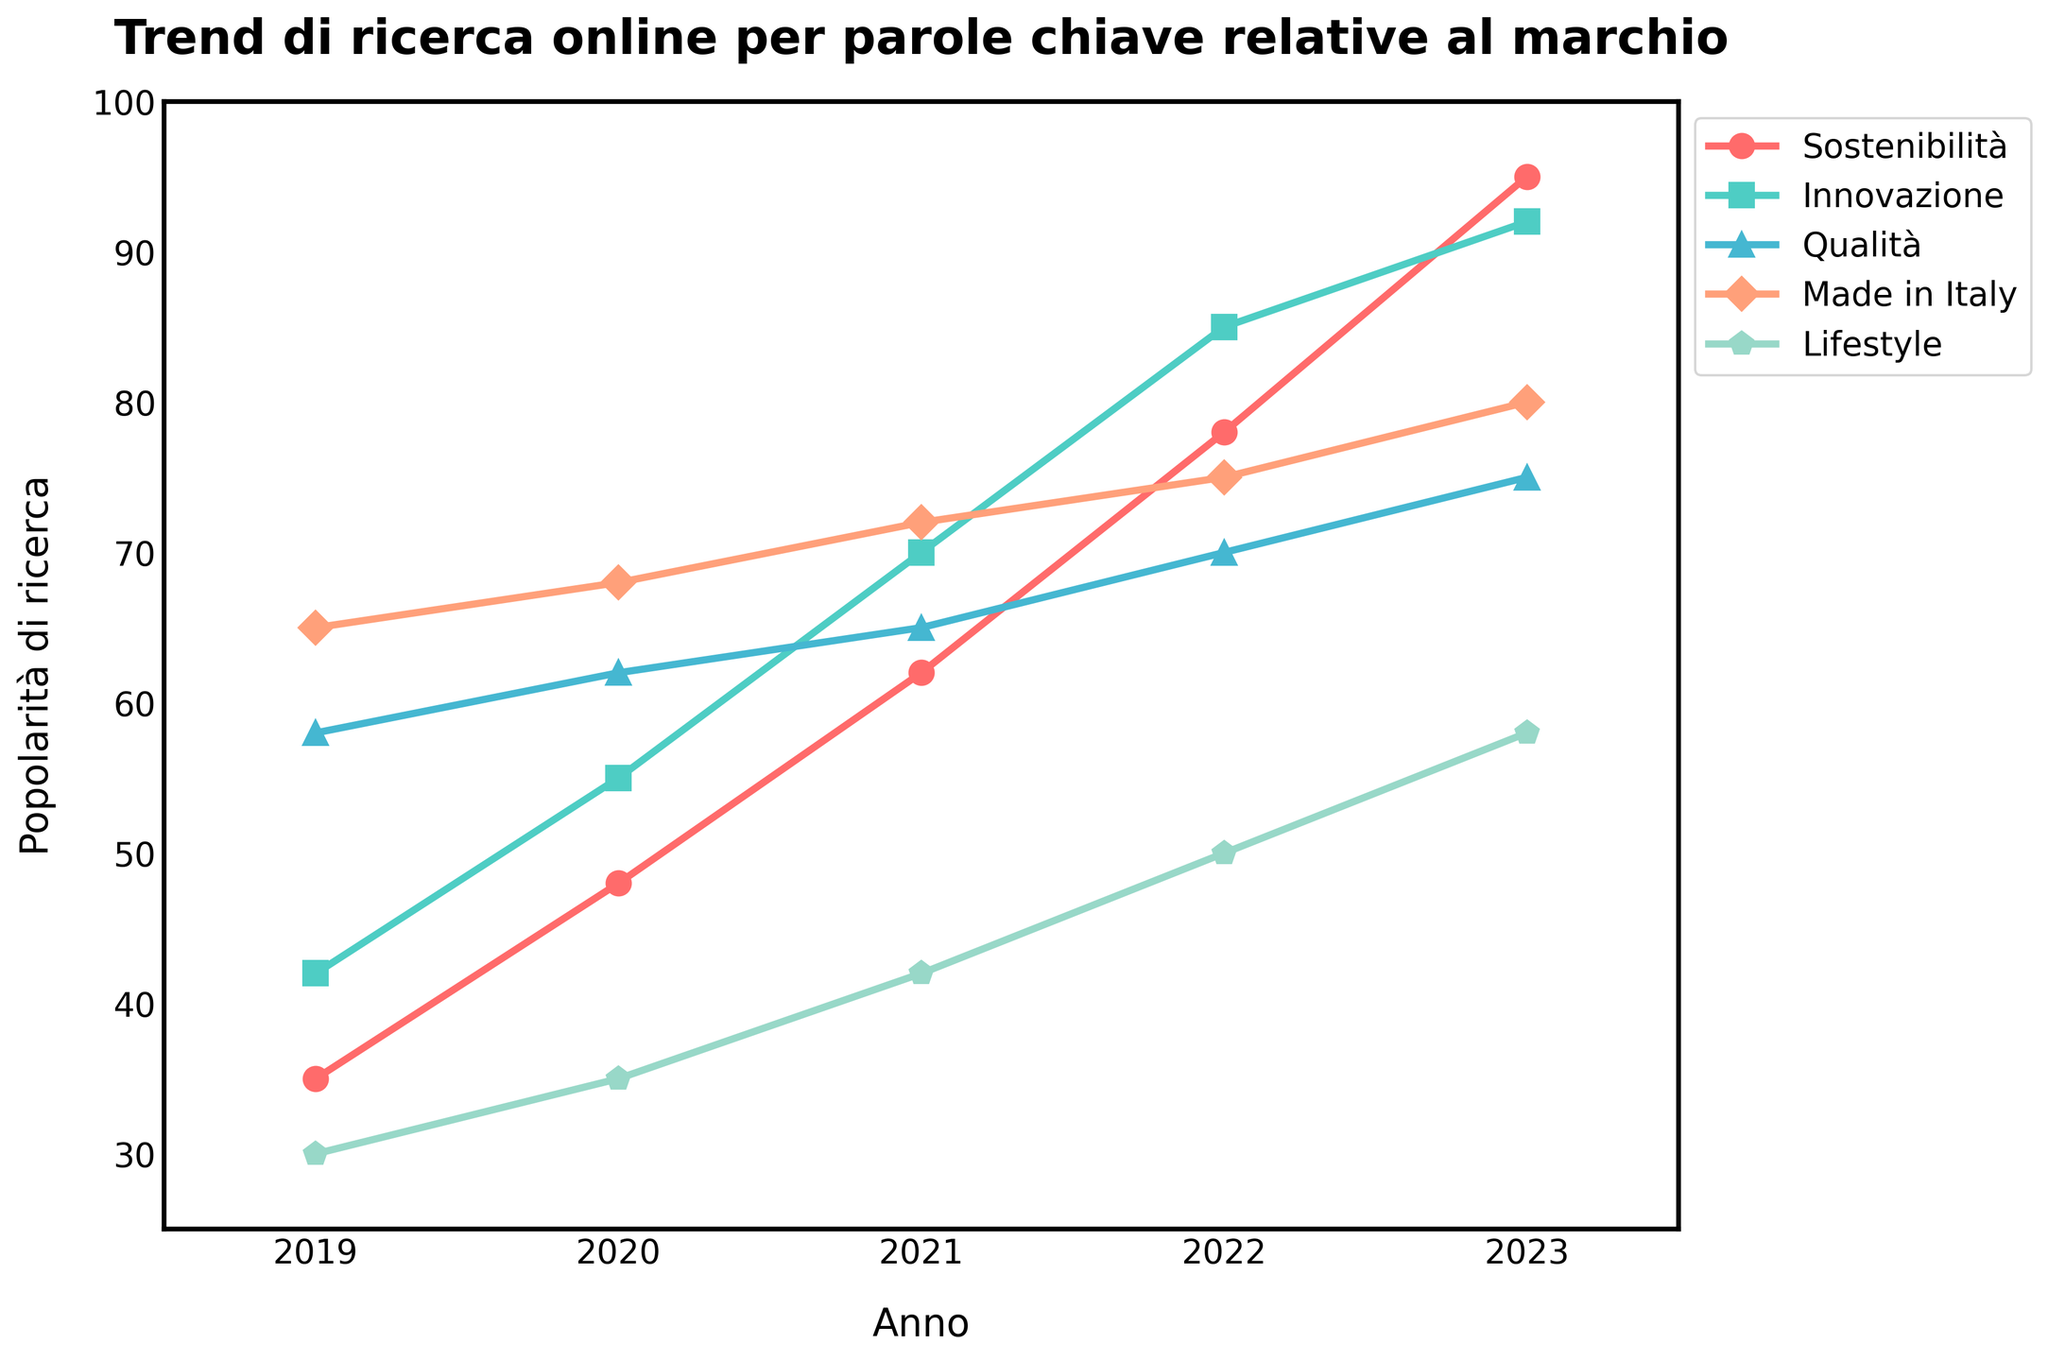What's the trend in search popularity for "Sostenibilità" over the last 5 years? To identify the trend, examine the plotted line for "Sostenibilità". We observe that the line consistently increases from 35 in 2019 to 95 in 2023.
Answer: Increasing Which keyword had the highest search popularity in 2023? In 2023, compare the values for each keyword. "Sostenibilità" has a popularity of 95, "Innovazione" has 92, "Qualità" has 75, "Made in Italy" has 80, and "Lifestyle" has 58. "Sostenibilità" is the highest.
Answer: Sostenibilità How many keywords had a popularity score of 70 or higher in 2022? Look at the values for each keyword in 2022. "Sostenibilità" is 78, "Innovazione" is 85, "Qualità" is 70, "Made in Italy" is 75, "Lifestyle" is 50. Count the keywords with a score of 70 or higher: 3 keywords ("Sostenibilità", "Innovazione", "Qualità", "Made in Italy").
Answer: 4 What's the difference in search popularity between "Made in Italy" and "Lifestyle" in 2023? Find the values in 2023 for both keywords: "Made in Italy" is 80, and "Lifestyle" is 58. Subtract the two values: 80 - 58 = 22.
Answer: 22 Which keyword experienced the largest increase in search popularity from 2019 to 2023? Calculate the difference for each keyword between 2019 and 2023: "Sostenibilità" (95-35=60), "Innovazione" (92-42=50), "Qualità" (75-58=17), "Made in Italy" (80-65=15), "Lifestyle" (58-30=28). "Sostenibilità" experienced the largest increase.
Answer: Sostenibilità In which year was the search popularity for "Innovazione" closest to 70? Inspect the values for "Innovazione": 2019 (42), 2020 (55), 2021 (70), 2022 (85), 2023 (92). The search popularity was exactly 70 in 2021.
Answer: 2021 What was the average search popularity for "Qualità" from 2019 to 2023? Calculate the sum of the values: 58 (2019) + 62 (2020) + 65 (2021) + 70 (2022) + 75 (2023) = 330. Then, divide by 5 (the number of years): 330 / 5 = 66.
Answer: 66 